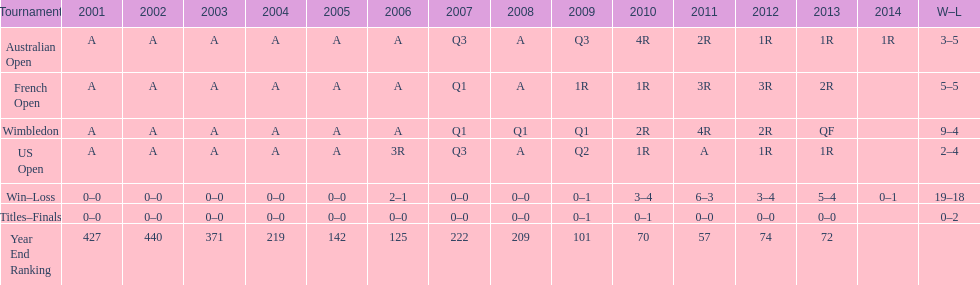What tournament has 5-5 as it's "w-l" record? French Open. 